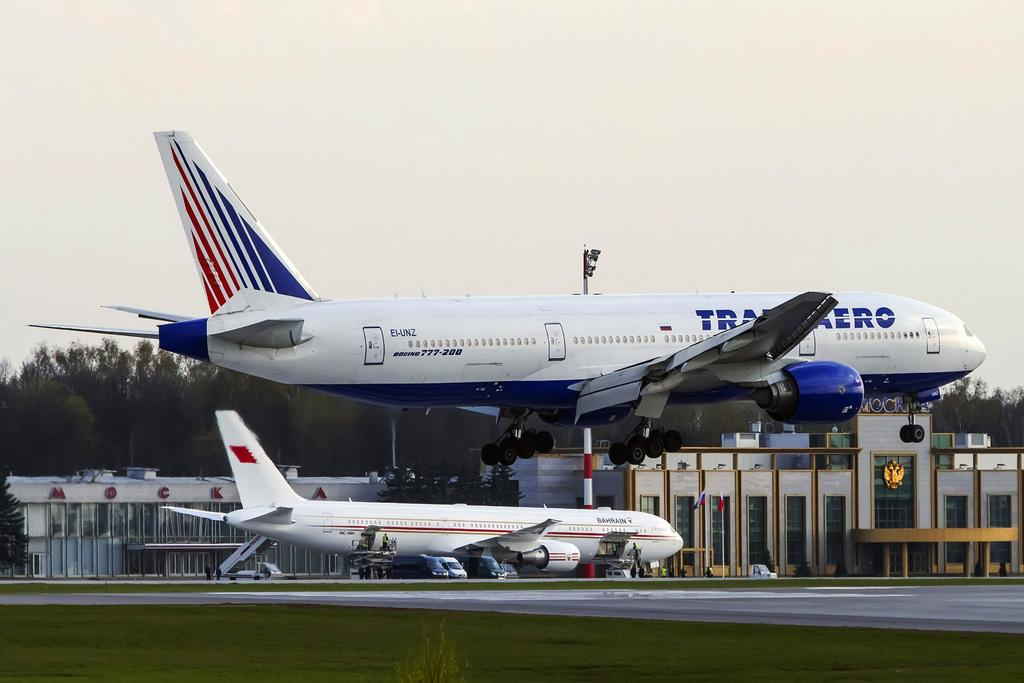<image>
Describe the image concisely. A white, red and blue airplane that displays the number 777-200 